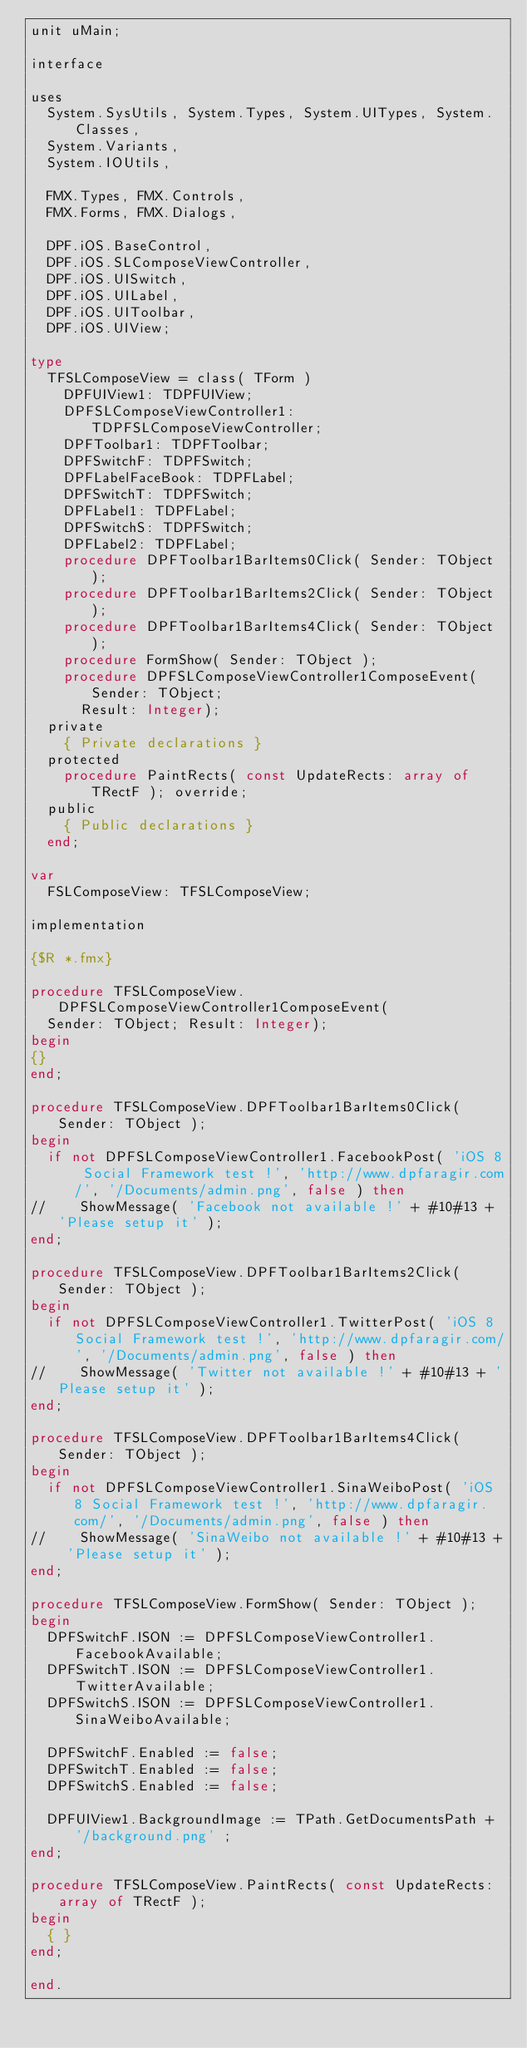<code> <loc_0><loc_0><loc_500><loc_500><_Pascal_>unit uMain;

interface

uses
  System.SysUtils, System.Types, System.UITypes, System.Classes,
  System.Variants,
  System.IOUtils,

  FMX.Types, FMX.Controls,
  FMX.Forms, FMX.Dialogs,

  DPF.iOS.BaseControl,
  DPF.iOS.SLComposeViewController,
  DPF.iOS.UISwitch,
  DPF.iOS.UILabel,
  DPF.iOS.UIToolbar,
  DPF.iOS.UIView;

type
  TFSLComposeView = class( TForm )
    DPFUIView1: TDPFUIView;
    DPFSLComposeViewController1: TDPFSLComposeViewController;
    DPFToolbar1: TDPFToolbar;
    DPFSwitchF: TDPFSwitch;
    DPFLabelFaceBook: TDPFLabel;
    DPFSwitchT: TDPFSwitch;
    DPFLabel1: TDPFLabel;
    DPFSwitchS: TDPFSwitch;
    DPFLabel2: TDPFLabel;
    procedure DPFToolbar1BarItems0Click( Sender: TObject );
    procedure DPFToolbar1BarItems2Click( Sender: TObject );
    procedure DPFToolbar1BarItems4Click( Sender: TObject );
    procedure FormShow( Sender: TObject );
    procedure DPFSLComposeViewController1ComposeEvent(Sender: TObject;
      Result: Integer);
  private
    { Private declarations }
  protected
    procedure PaintRects( const UpdateRects: array of TRectF ); override;
  public
    { Public declarations }
  end;

var
  FSLComposeView: TFSLComposeView;

implementation

{$R *.fmx}

procedure TFSLComposeView.DPFSLComposeViewController1ComposeEvent(
  Sender: TObject; Result: Integer);
begin
{}
end;

procedure TFSLComposeView.DPFToolbar1BarItems0Click( Sender: TObject );
begin
  if not DPFSLComposeViewController1.FacebookPost( 'iOS 8 Social Framework test !', 'http://www.dpfaragir.com/', '/Documents/admin.png', false ) then
//    ShowMessage( 'Facebook not available !' + #10#13 + 'Please setup it' );
end;

procedure TFSLComposeView.DPFToolbar1BarItems2Click( Sender: TObject );
begin
  if not DPFSLComposeViewController1.TwitterPost( 'iOS 8 Social Framework test !', 'http://www.dpfaragir.com/', '/Documents/admin.png', false ) then
//    ShowMessage( 'Twitter not available !' + #10#13 + 'Please setup it' );
end;

procedure TFSLComposeView.DPFToolbar1BarItems4Click( Sender: TObject );
begin
  if not DPFSLComposeViewController1.SinaWeiboPost( 'iOS 8 Social Framework test !', 'http://www.dpfaragir.com/', '/Documents/admin.png', false ) then
//    ShowMessage( 'SinaWeibo not available !' + #10#13 + 'Please setup it' );
end;

procedure TFSLComposeView.FormShow( Sender: TObject );
begin
  DPFSwitchF.ISON := DPFSLComposeViewController1.FacebookAvailable;
  DPFSwitchT.ISON := DPFSLComposeViewController1.TwitterAvailable;
  DPFSwitchS.ISON := DPFSLComposeViewController1.SinaWeiboAvailable;

  DPFSwitchF.Enabled := false;
  DPFSwitchT.Enabled := false;
  DPFSwitchS.Enabled := false;

  DPFUIView1.BackgroundImage := TPath.GetDocumentsPath + '/background.png' ;
end;

procedure TFSLComposeView.PaintRects( const UpdateRects: array of TRectF );
begin
  { }
end;

end.
</code> 